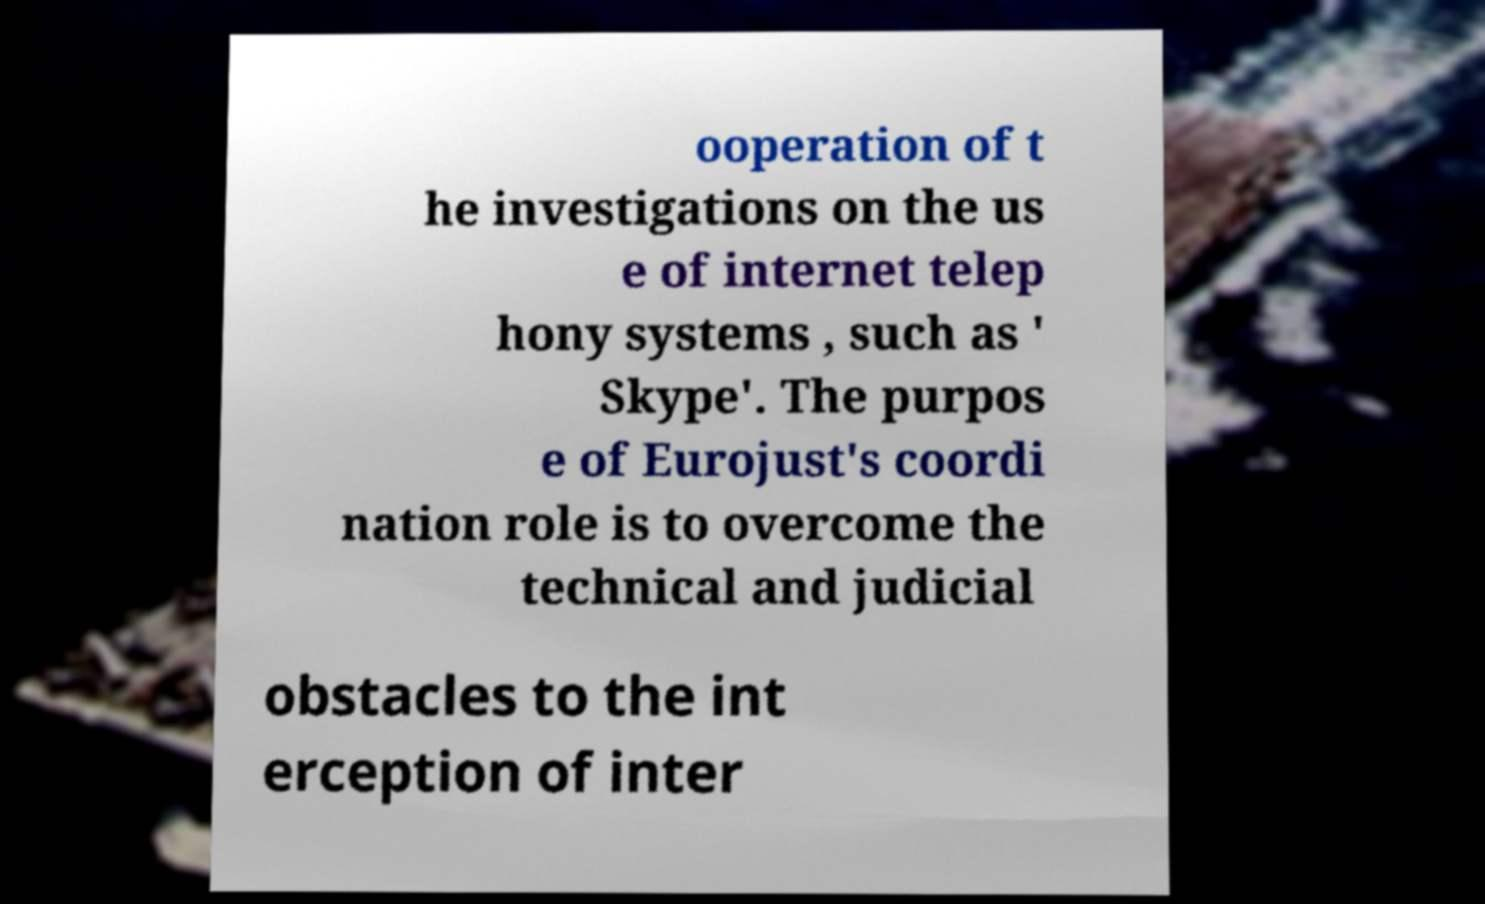Please read and relay the text visible in this image. What does it say? ooperation of t he investigations on the us e of internet telep hony systems , such as ' Skype'. The purpos e of Eurojust's coordi nation role is to overcome the technical and judicial obstacles to the int erception of inter 